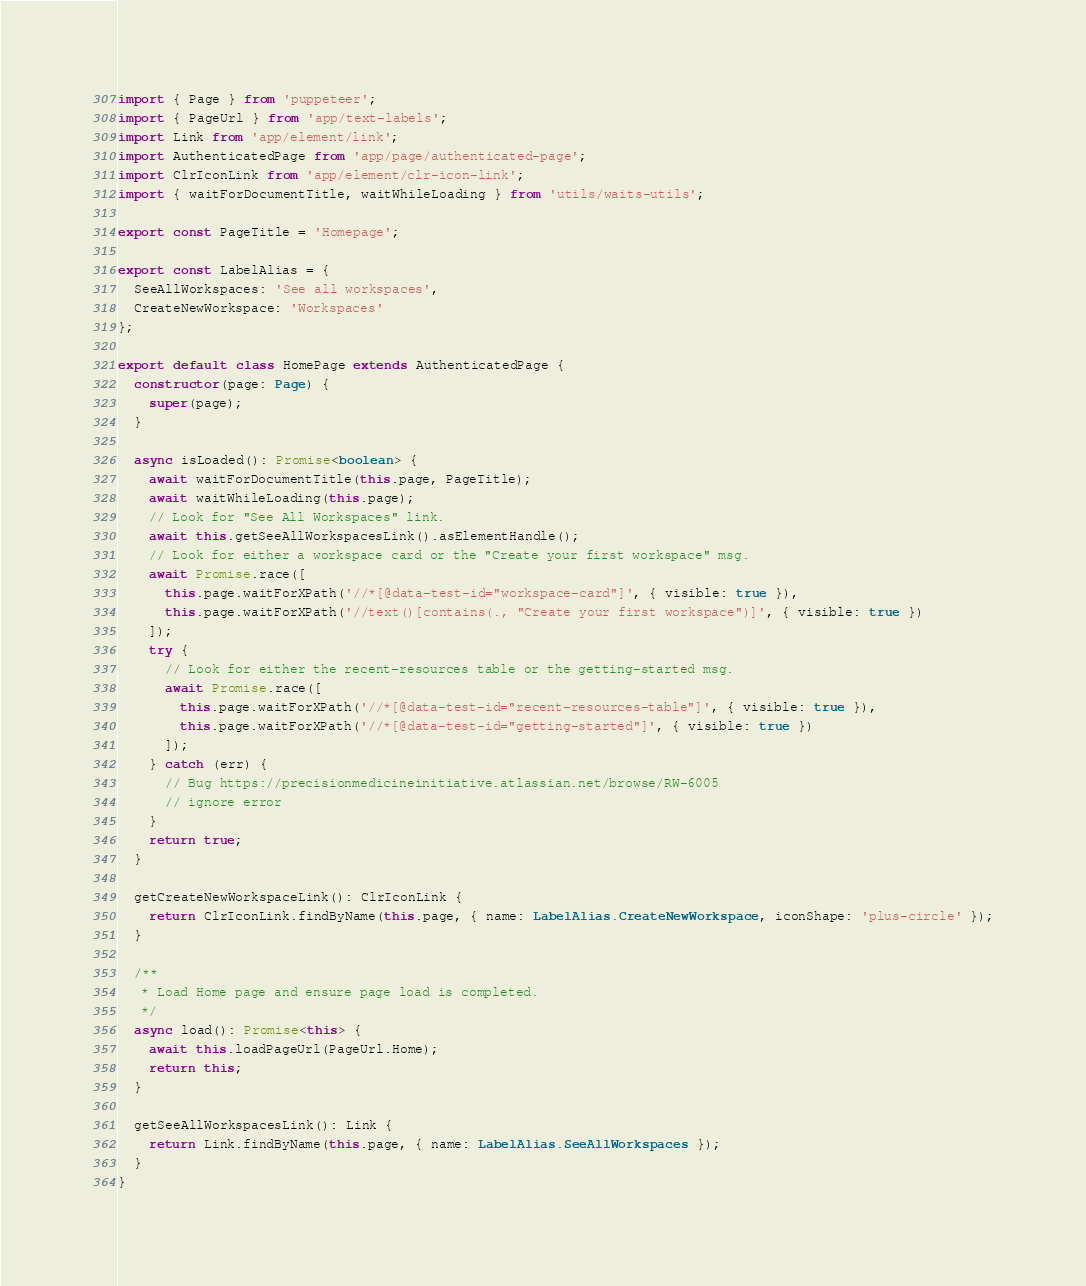<code> <loc_0><loc_0><loc_500><loc_500><_TypeScript_>import { Page } from 'puppeteer';
import { PageUrl } from 'app/text-labels';
import Link from 'app/element/link';
import AuthenticatedPage from 'app/page/authenticated-page';
import ClrIconLink from 'app/element/clr-icon-link';
import { waitForDocumentTitle, waitWhileLoading } from 'utils/waits-utils';

export const PageTitle = 'Homepage';

export const LabelAlias = {
  SeeAllWorkspaces: 'See all workspaces',
  CreateNewWorkspace: 'Workspaces'
};

export default class HomePage extends AuthenticatedPage {
  constructor(page: Page) {
    super(page);
  }

  async isLoaded(): Promise<boolean> {
    await waitForDocumentTitle(this.page, PageTitle);
    await waitWhileLoading(this.page);
    // Look for "See All Workspaces" link.
    await this.getSeeAllWorkspacesLink().asElementHandle();
    // Look for either a workspace card or the "Create your first workspace" msg.
    await Promise.race([
      this.page.waitForXPath('//*[@data-test-id="workspace-card"]', { visible: true }),
      this.page.waitForXPath('//text()[contains(., "Create your first workspace")]', { visible: true })
    ]);
    try {
      // Look for either the recent-resources table or the getting-started msg.
      await Promise.race([
        this.page.waitForXPath('//*[@data-test-id="recent-resources-table"]', { visible: true }),
        this.page.waitForXPath('//*[@data-test-id="getting-started"]', { visible: true })
      ]);
    } catch (err) {
      // Bug https://precisionmedicineinitiative.atlassian.net/browse/RW-6005
      // ignore error
    }
    return true;
  }

  getCreateNewWorkspaceLink(): ClrIconLink {
    return ClrIconLink.findByName(this.page, { name: LabelAlias.CreateNewWorkspace, iconShape: 'plus-circle' });
  }

  /**
   * Load Home page and ensure page load is completed.
   */
  async load(): Promise<this> {
    await this.loadPageUrl(PageUrl.Home);
    return this;
  }

  getSeeAllWorkspacesLink(): Link {
    return Link.findByName(this.page, { name: LabelAlias.SeeAllWorkspaces });
  }
}
</code> 